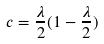Convert formula to latex. <formula><loc_0><loc_0><loc_500><loc_500>c = \frac { \lambda } { 2 } ( 1 - \frac { \lambda } { 2 } )</formula> 